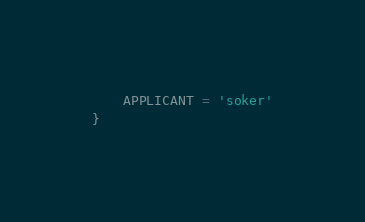<code> <loc_0><loc_0><loc_500><loc_500><_TypeScript_>    APPLICANT = 'soker'
}
</code> 